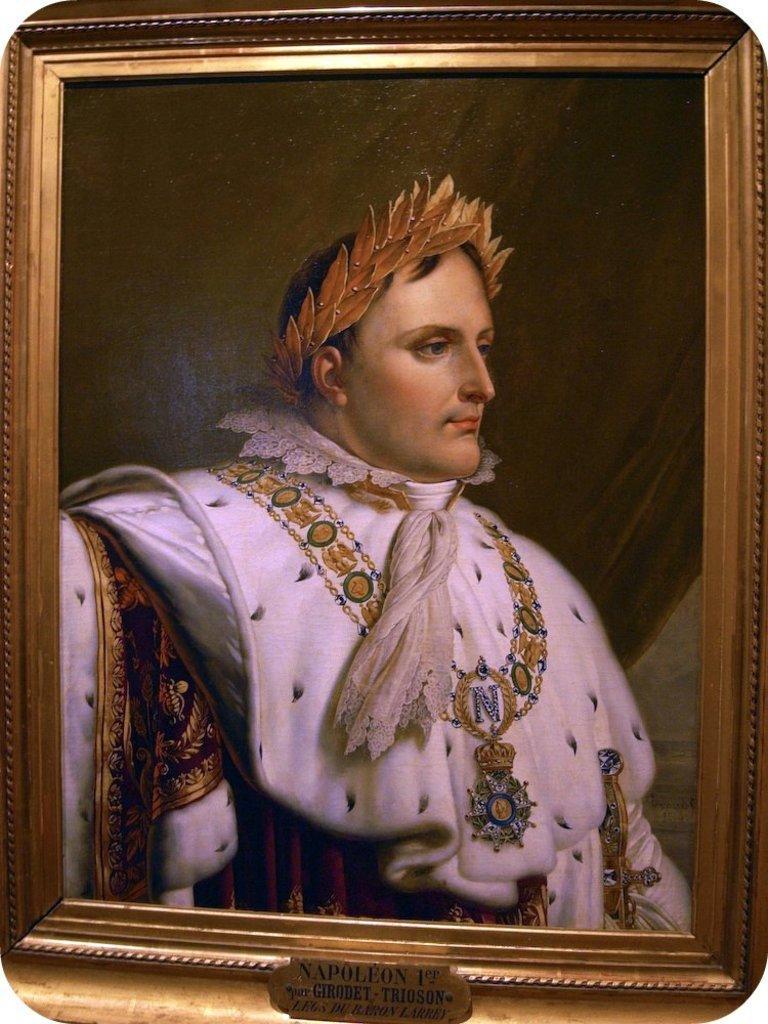Describe this image in one or two sentences. This picture shows a photo frame. We see a man and we see a name plate with some text on it is fixed to the photo frame. 